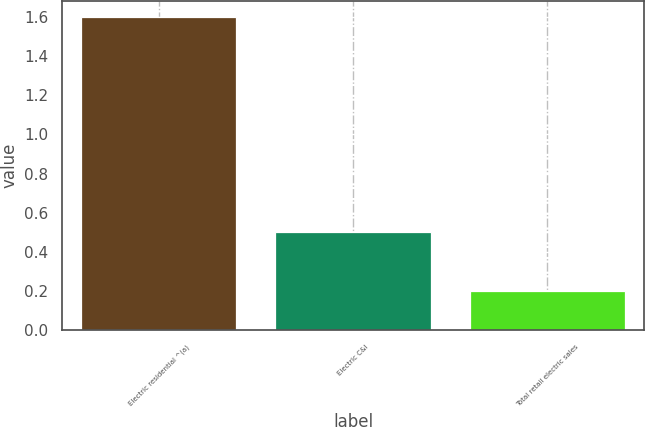<chart> <loc_0><loc_0><loc_500><loc_500><bar_chart><fcel>Electric residential ^(a)<fcel>Electric C&I<fcel>Total retail electric sales<nl><fcel>1.6<fcel>0.5<fcel>0.2<nl></chart> 